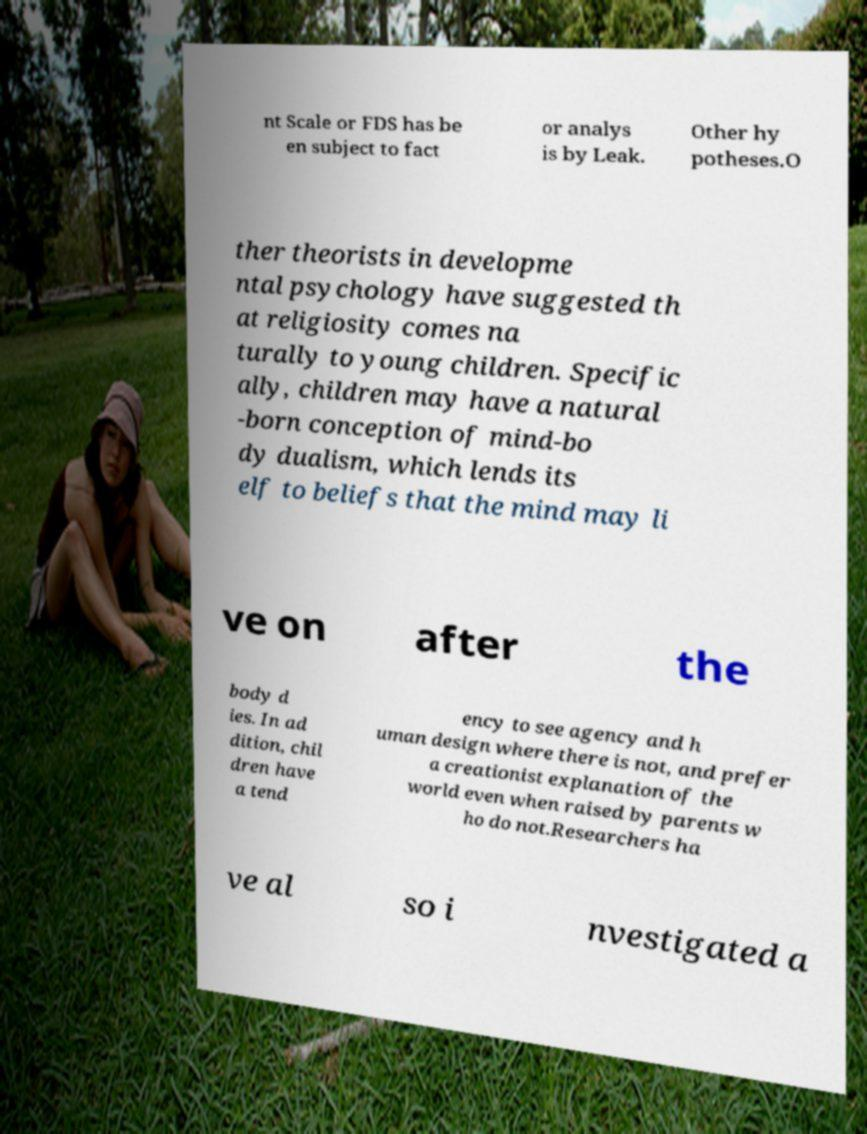What messages or text are displayed in this image? I need them in a readable, typed format. nt Scale or FDS has be en subject to fact or analys is by Leak. Other hy potheses.O ther theorists in developme ntal psychology have suggested th at religiosity comes na turally to young children. Specific ally, children may have a natural -born conception of mind-bo dy dualism, which lends its elf to beliefs that the mind may li ve on after the body d ies. In ad dition, chil dren have a tend ency to see agency and h uman design where there is not, and prefer a creationist explanation of the world even when raised by parents w ho do not.Researchers ha ve al so i nvestigated a 